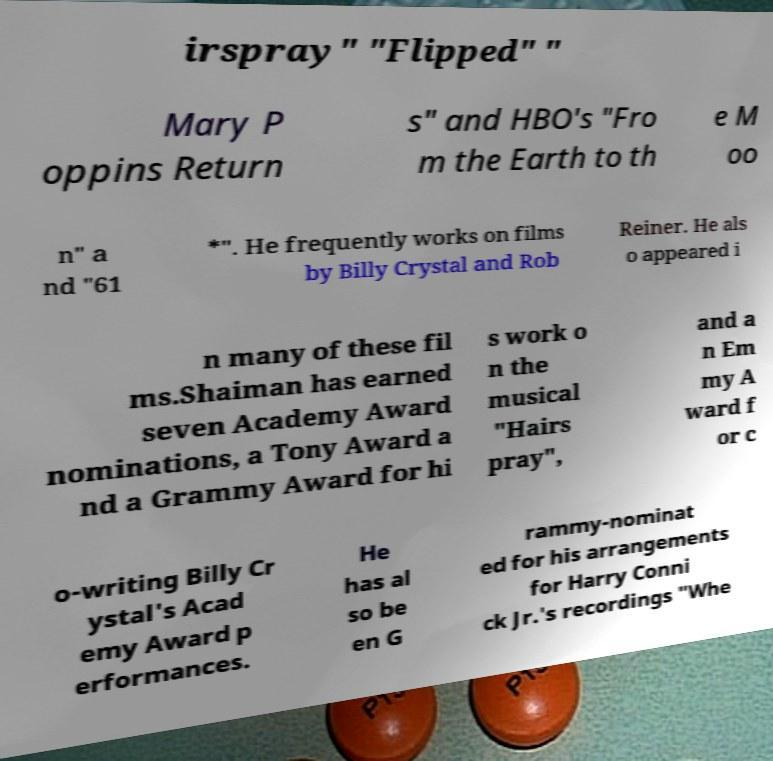Please identify and transcribe the text found in this image. irspray" "Flipped" " Mary P oppins Return s" and HBO's "Fro m the Earth to th e M oo n" a nd "61 *". He frequently works on films by Billy Crystal and Rob Reiner. He als o appeared i n many of these fil ms.Shaiman has earned seven Academy Award nominations, a Tony Award a nd a Grammy Award for hi s work o n the musical "Hairs pray", and a n Em my A ward f or c o-writing Billy Cr ystal's Acad emy Award p erformances. He has al so be en G rammy-nominat ed for his arrangements for Harry Conni ck Jr.'s recordings "Whe 